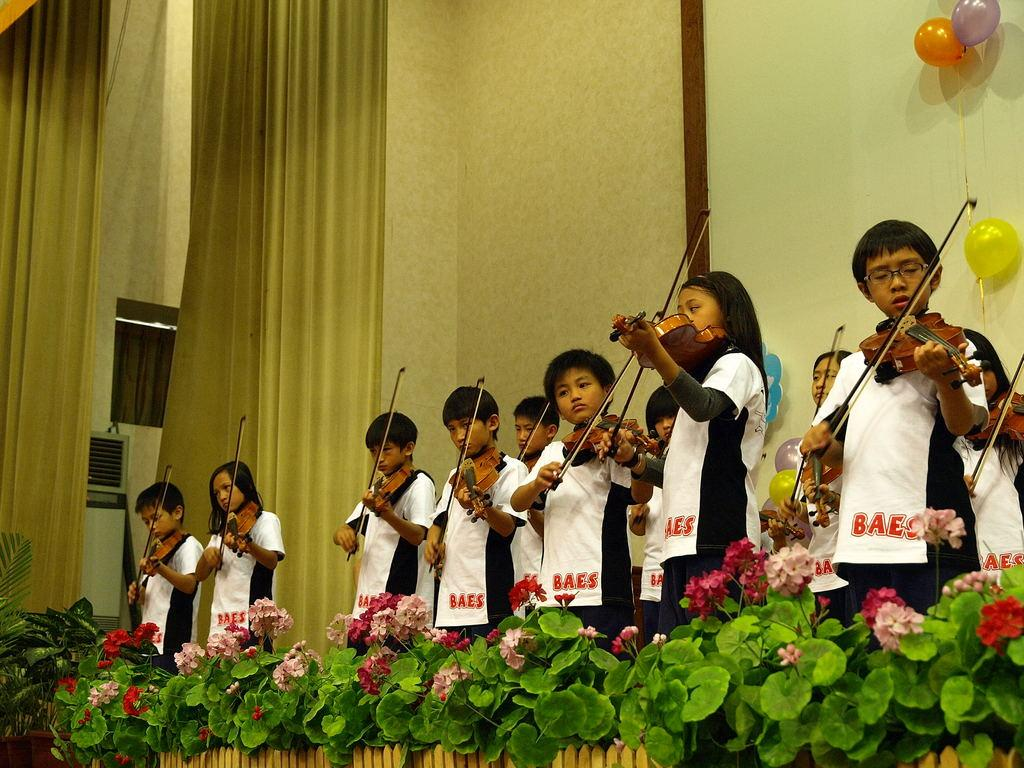What are the people in the image doing? The people in the image are playing violins. What object can be seen in the image that is not related to the violins? There is a cloth in the image. What decoration is present on the wall in the image? There is a balloon on the wall in the image. How is the stage arranged in the image? The stage is arranged with flowers. What type of whistle can be heard during the performance in the image? There is no whistle present or audible in the image; it only shows people playing violins. 